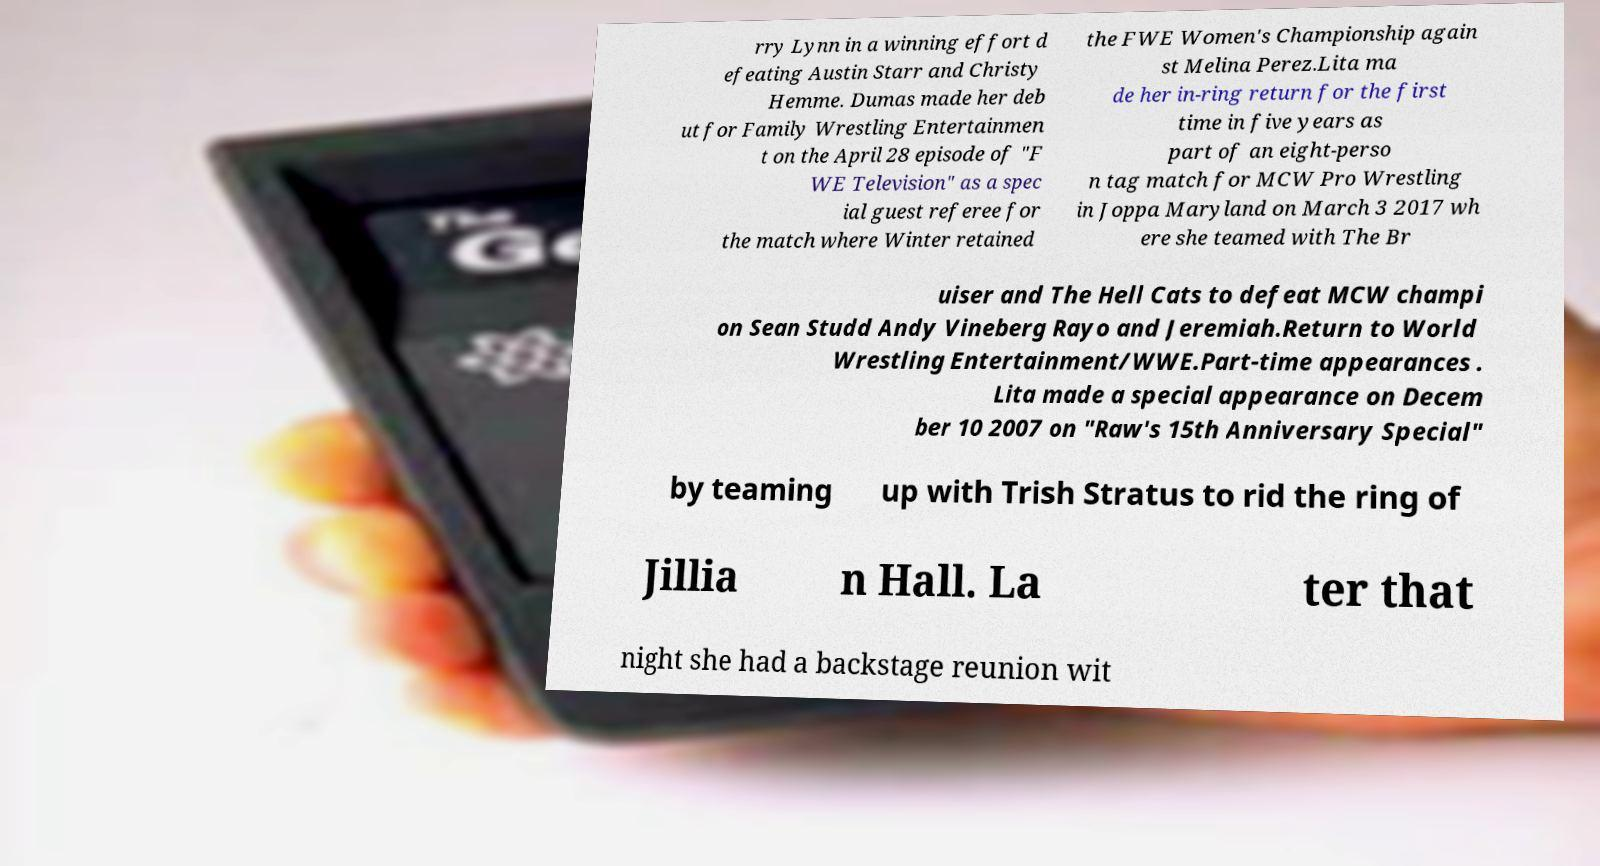What messages or text are displayed in this image? I need them in a readable, typed format. rry Lynn in a winning effort d efeating Austin Starr and Christy Hemme. Dumas made her deb ut for Family Wrestling Entertainmen t on the April 28 episode of "F WE Television" as a spec ial guest referee for the match where Winter retained the FWE Women's Championship again st Melina Perez.Lita ma de her in-ring return for the first time in five years as part of an eight-perso n tag match for MCW Pro Wrestling in Joppa Maryland on March 3 2017 wh ere she teamed with The Br uiser and The Hell Cats to defeat MCW champi on Sean Studd Andy Vineberg Rayo and Jeremiah.Return to World Wrestling Entertainment/WWE.Part-time appearances . Lita made a special appearance on Decem ber 10 2007 on "Raw's 15th Anniversary Special" by teaming up with Trish Stratus to rid the ring of Jillia n Hall. La ter that night she had a backstage reunion wit 